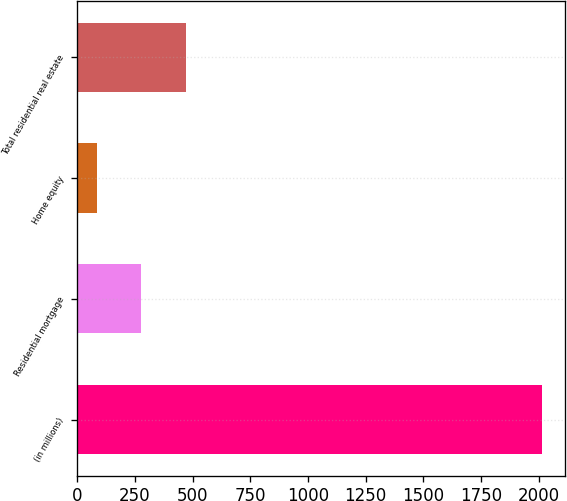<chart> <loc_0><loc_0><loc_500><loc_500><bar_chart><fcel>(in millions)<fcel>Residential mortgage<fcel>Home equity<fcel>Total residential real estate<nl><fcel>2015<fcel>278<fcel>85<fcel>471<nl></chart> 